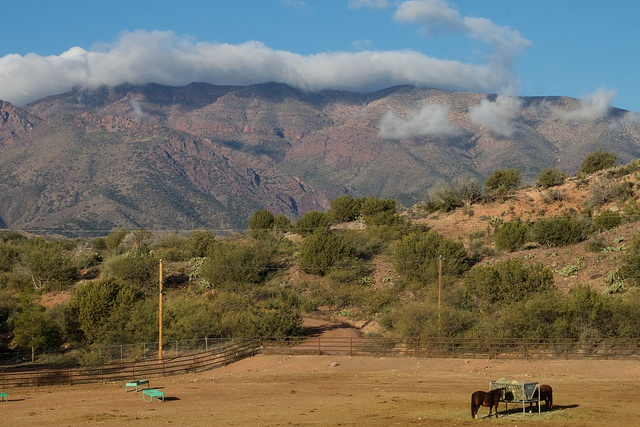Describe the objects in this image and their specific colors. I can see horse in gray, black, maroon, olive, and tan tones, horse in gray, black, maroon, and olive tones, and bench in gray, turquoise, green, and olive tones in this image. 